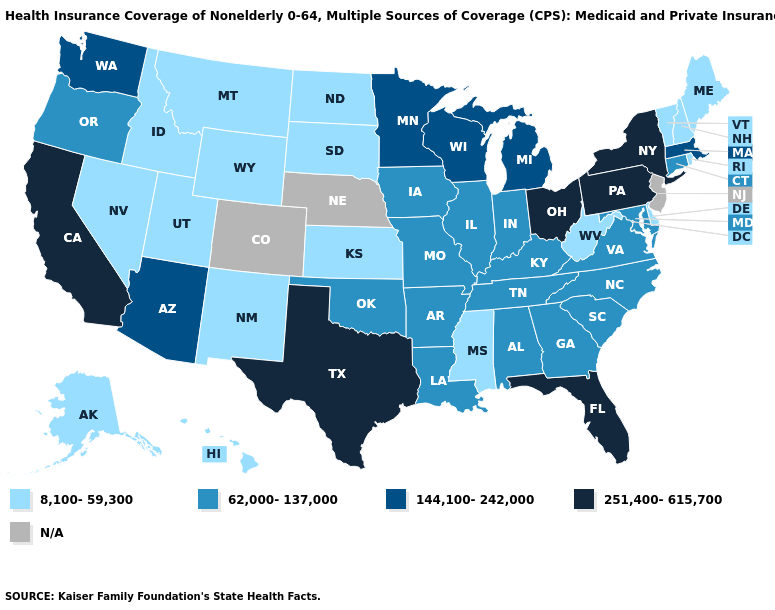What is the value of Illinois?
Be succinct. 62,000-137,000. What is the highest value in the Northeast ?
Keep it brief. 251,400-615,700. Name the states that have a value in the range 144,100-242,000?
Quick response, please. Arizona, Massachusetts, Michigan, Minnesota, Washington, Wisconsin. Which states have the lowest value in the USA?
Write a very short answer. Alaska, Delaware, Hawaii, Idaho, Kansas, Maine, Mississippi, Montana, Nevada, New Hampshire, New Mexico, North Dakota, Rhode Island, South Dakota, Utah, Vermont, West Virginia, Wyoming. Among the states that border Illinois , does Wisconsin have the lowest value?
Give a very brief answer. No. Which states have the lowest value in the USA?
Answer briefly. Alaska, Delaware, Hawaii, Idaho, Kansas, Maine, Mississippi, Montana, Nevada, New Hampshire, New Mexico, North Dakota, Rhode Island, South Dakota, Utah, Vermont, West Virginia, Wyoming. Which states hav the highest value in the West?
Answer briefly. California. Name the states that have a value in the range 62,000-137,000?
Quick response, please. Alabama, Arkansas, Connecticut, Georgia, Illinois, Indiana, Iowa, Kentucky, Louisiana, Maryland, Missouri, North Carolina, Oklahoma, Oregon, South Carolina, Tennessee, Virginia. What is the value of North Dakota?
Keep it brief. 8,100-59,300. Name the states that have a value in the range 62,000-137,000?
Give a very brief answer. Alabama, Arkansas, Connecticut, Georgia, Illinois, Indiana, Iowa, Kentucky, Louisiana, Maryland, Missouri, North Carolina, Oklahoma, Oregon, South Carolina, Tennessee, Virginia. What is the highest value in the USA?
Keep it brief. 251,400-615,700. What is the highest value in the USA?
Answer briefly. 251,400-615,700. What is the value of Alaska?
Quick response, please. 8,100-59,300. Which states have the lowest value in the MidWest?
Write a very short answer. Kansas, North Dakota, South Dakota. 